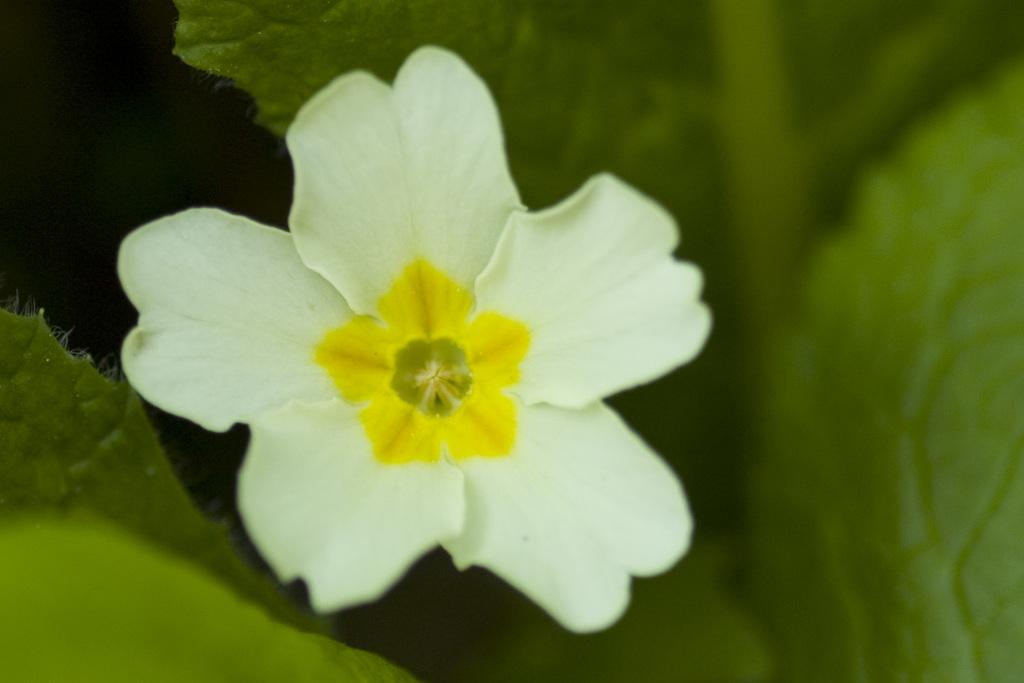What is the main subject of the image? There is a flower in the image. Can you describe the colors of the flower? The flower has white and yellow colors. What else is present along with the flower? There are leaves associated with the flower. How many babies are playing with soap in the image? There are no babies or soap present in the image; it features a flower with leaves. What type of burst can be seen in the image? There is no burst present in the image; it features a flower with leaves. 